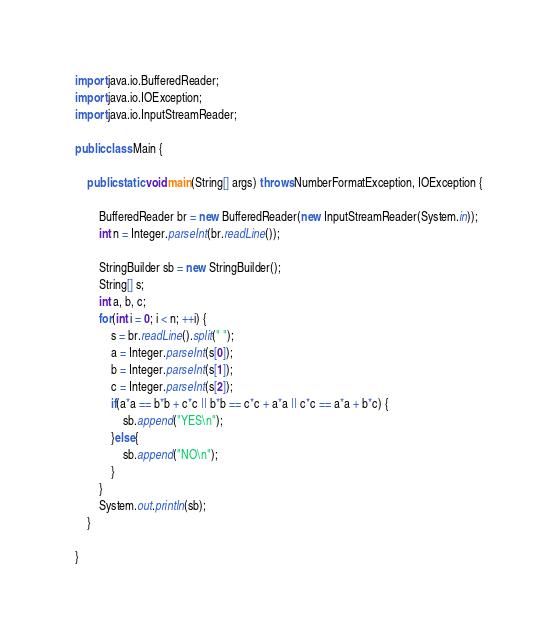Convert code to text. <code><loc_0><loc_0><loc_500><loc_500><_Java_>import java.io.BufferedReader;
import java.io.IOException;
import java.io.InputStreamReader;

public class Main {

	public static void main(String[] args) throws NumberFormatException, IOException {
		
		BufferedReader br = new BufferedReader(new InputStreamReader(System.in));
		int n = Integer.parseInt(br.readLine());
		
		StringBuilder sb = new StringBuilder();
		String[] s;
		int a, b, c;
		for(int i = 0; i < n; ++i) {
			s = br.readLine().split(" ");
			a = Integer.parseInt(s[0]);
			b = Integer.parseInt(s[1]);
			c = Integer.parseInt(s[2]);
			if(a*a == b*b + c*c || b*b == c*c + a*a || c*c == a*a + b*c) {
				sb.append("YES\n");
			}else{
				sb.append("NO\n");
			}
		}
		System.out.println(sb);
	}

}</code> 